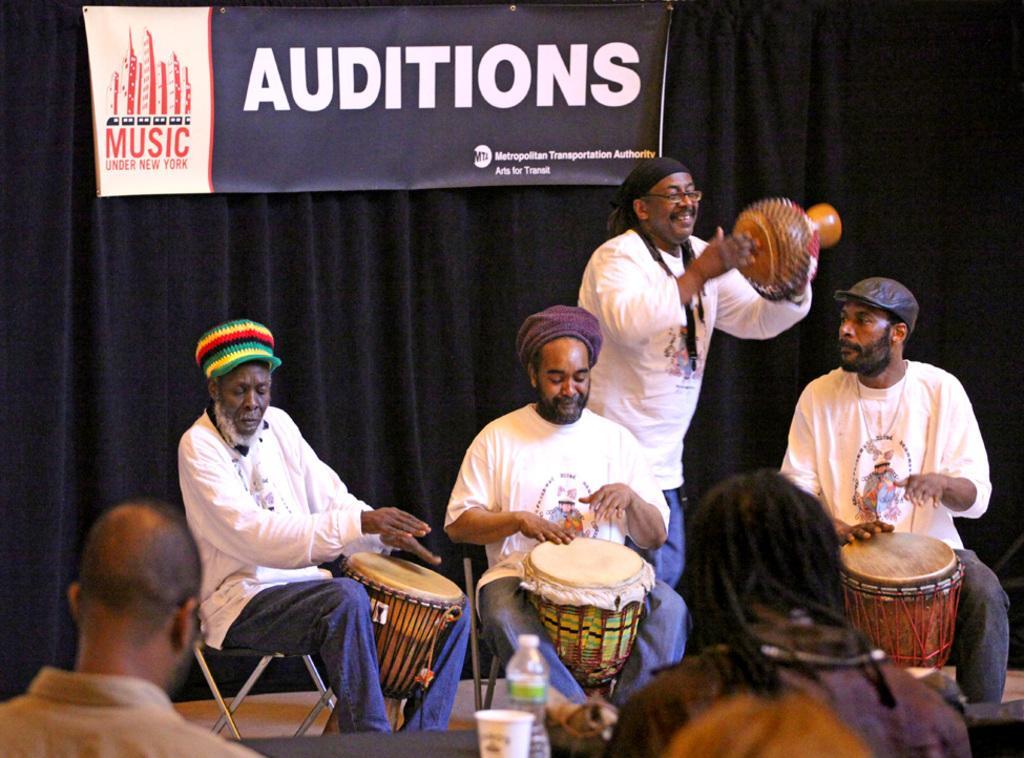Could you give a brief overview of what you see in this image? In this picture there are group of people who are playing musical instruments. There is a bottle , cup on the table. There is a curtain and a banner at the background. 